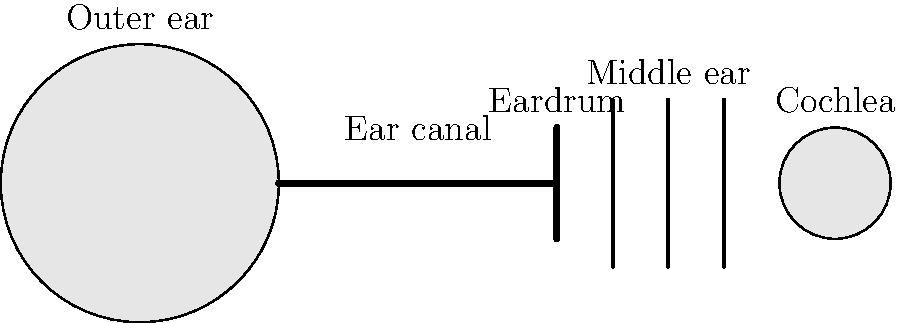As you listen to the retired musician's melodies from the front porch, consider how your ear processes these musical tones. Using the labeled cross-section diagram of the human ear, explain the path that sound waves take from the outer ear to the cochlea, and describe how the cochlea converts these waves into electrical signals that your brain interprets as music. 1. Sound waves enter the outer ear: The retired musician's melodies create sound waves that are collected by the outer ear (pinna) and funneled into the ear canal.

2. Travel through the ear canal: The sound waves travel through the ear canal, which amplifies and directs them towards the eardrum.

3. Eardrum vibration: When the sound waves reach the eardrum (tympanic membrane), they cause it to vibrate at the same frequency as the incoming sound waves.

4. Middle ear bones: The vibrations from the eardrum are transmitted to the three small bones in the middle ear (ossicles: malleus, incus, and stapes). These bones amplify the vibrations and transfer them to the inner ear.

5. Cochlea stimulation: The stapes bone connects to the oval window of the cochlea, causing the fluid inside the cochlea to move.

6. Hair cell activation: The movement of fluid in the cochlea causes tiny hair cells to bend. Different frequencies of sound cause different parts of the cochlea to resonate, activating specific hair cells.

7. Electrical signal generation: When the hair cells bend, they generate electrical signals.

8. Signal transmission: These electrical signals are sent via the auditory nerve to the brain.

9. Brain interpretation: The brain processes these electrical signals and interprets them as the beautiful melodies you hear from the retired musician.

The cochlea's ability to distinguish between different frequencies allows you to perceive the various musical tones in the melodies. The cochlea is tonotopically organized, meaning that different regions respond to different frequencies, with high frequencies detected near the base and low frequencies near the apex.
Answer: Sound waves enter outer ear, travel through ear canal, vibrate eardrum, move middle ear bones, stimulate cochlea fluid, bend hair cells, generate electrical signals interpreted by brain as music. 